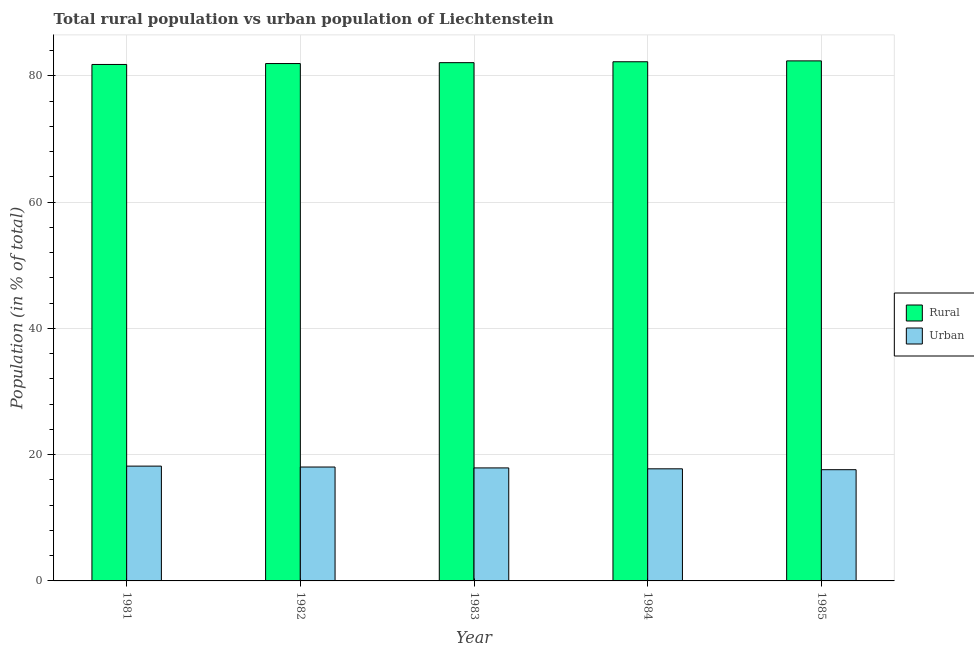How many groups of bars are there?
Ensure brevity in your answer.  5. Are the number of bars per tick equal to the number of legend labels?
Make the answer very short. Yes. How many bars are there on the 2nd tick from the left?
Your response must be concise. 2. In how many cases, is the number of bars for a given year not equal to the number of legend labels?
Provide a short and direct response. 0. What is the rural population in 1984?
Offer a very short reply. 82.24. Across all years, what is the maximum urban population?
Give a very brief answer. 18.19. Across all years, what is the minimum rural population?
Make the answer very short. 81.81. In which year was the urban population maximum?
Offer a terse response. 1981. What is the total rural population in the graph?
Provide a succinct answer. 410.49. What is the difference between the urban population in 1983 and that in 1985?
Provide a succinct answer. 0.28. What is the difference between the rural population in 1985 and the urban population in 1982?
Provide a succinct answer. 0.42. What is the average urban population per year?
Offer a very short reply. 17.9. In the year 1981, what is the difference between the rural population and urban population?
Provide a short and direct response. 0. What is the ratio of the urban population in 1982 to that in 1984?
Keep it short and to the point. 1.02. Is the rural population in 1982 less than that in 1983?
Your answer should be compact. Yes. What is the difference between the highest and the second highest rural population?
Offer a terse response. 0.14. What is the difference between the highest and the lowest rural population?
Give a very brief answer. 0.57. Is the sum of the urban population in 1981 and 1983 greater than the maximum rural population across all years?
Your answer should be compact. Yes. What does the 2nd bar from the left in 1981 represents?
Your answer should be compact. Urban. What does the 2nd bar from the right in 1984 represents?
Your answer should be compact. Rural. Does the graph contain any zero values?
Offer a very short reply. No. What is the title of the graph?
Give a very brief answer. Total rural population vs urban population of Liechtenstein. What is the label or title of the Y-axis?
Give a very brief answer. Population (in % of total). What is the Population (in % of total) in Rural in 1981?
Offer a terse response. 81.81. What is the Population (in % of total) in Urban in 1981?
Provide a short and direct response. 18.19. What is the Population (in % of total) in Rural in 1982?
Offer a terse response. 81.96. What is the Population (in % of total) of Urban in 1982?
Your response must be concise. 18.04. What is the Population (in % of total) of Rural in 1983?
Your answer should be very brief. 82.1. What is the Population (in % of total) in Urban in 1983?
Ensure brevity in your answer.  17.9. What is the Population (in % of total) in Rural in 1984?
Provide a succinct answer. 82.24. What is the Population (in % of total) of Urban in 1984?
Your answer should be compact. 17.76. What is the Population (in % of total) in Rural in 1985?
Keep it short and to the point. 82.38. What is the Population (in % of total) in Urban in 1985?
Make the answer very short. 17.62. Across all years, what is the maximum Population (in % of total) in Rural?
Your response must be concise. 82.38. Across all years, what is the maximum Population (in % of total) in Urban?
Your answer should be very brief. 18.19. Across all years, what is the minimum Population (in % of total) in Rural?
Provide a succinct answer. 81.81. Across all years, what is the minimum Population (in % of total) of Urban?
Offer a terse response. 17.62. What is the total Population (in % of total) of Rural in the graph?
Offer a terse response. 410.49. What is the total Population (in % of total) in Urban in the graph?
Keep it short and to the point. 89.51. What is the difference between the Population (in % of total) of Rural in 1981 and that in 1982?
Your answer should be compact. -0.14. What is the difference between the Population (in % of total) of Urban in 1981 and that in 1982?
Offer a terse response. 0.14. What is the difference between the Population (in % of total) in Rural in 1981 and that in 1983?
Your response must be concise. -0.29. What is the difference between the Population (in % of total) of Urban in 1981 and that in 1983?
Provide a short and direct response. 0.29. What is the difference between the Population (in % of total) of Rural in 1981 and that in 1984?
Provide a succinct answer. -0.43. What is the difference between the Population (in % of total) in Urban in 1981 and that in 1984?
Make the answer very short. 0.43. What is the difference between the Population (in % of total) of Rural in 1981 and that in 1985?
Give a very brief answer. -0.57. What is the difference between the Population (in % of total) of Urban in 1981 and that in 1985?
Give a very brief answer. 0.57. What is the difference between the Population (in % of total) in Rural in 1982 and that in 1983?
Give a very brief answer. -0.14. What is the difference between the Population (in % of total) of Urban in 1982 and that in 1983?
Give a very brief answer. 0.14. What is the difference between the Population (in % of total) in Rural in 1982 and that in 1984?
Keep it short and to the point. -0.28. What is the difference between the Population (in % of total) of Urban in 1982 and that in 1984?
Your answer should be very brief. 0.28. What is the difference between the Population (in % of total) in Rural in 1982 and that in 1985?
Keep it short and to the point. -0.42. What is the difference between the Population (in % of total) of Urban in 1982 and that in 1985?
Your response must be concise. 0.42. What is the difference between the Population (in % of total) in Rural in 1983 and that in 1984?
Give a very brief answer. -0.14. What is the difference between the Population (in % of total) of Urban in 1983 and that in 1984?
Provide a short and direct response. 0.14. What is the difference between the Population (in % of total) of Rural in 1983 and that in 1985?
Your answer should be very brief. -0.28. What is the difference between the Population (in % of total) in Urban in 1983 and that in 1985?
Provide a short and direct response. 0.28. What is the difference between the Population (in % of total) in Rural in 1984 and that in 1985?
Your response must be concise. -0.14. What is the difference between the Population (in % of total) in Urban in 1984 and that in 1985?
Give a very brief answer. 0.14. What is the difference between the Population (in % of total) of Rural in 1981 and the Population (in % of total) of Urban in 1982?
Keep it short and to the point. 63.77. What is the difference between the Population (in % of total) of Rural in 1981 and the Population (in % of total) of Urban in 1983?
Make the answer very short. 63.91. What is the difference between the Population (in % of total) of Rural in 1981 and the Population (in % of total) of Urban in 1984?
Provide a succinct answer. 64.05. What is the difference between the Population (in % of total) of Rural in 1981 and the Population (in % of total) of Urban in 1985?
Make the answer very short. 64.19. What is the difference between the Population (in % of total) of Rural in 1982 and the Population (in % of total) of Urban in 1983?
Keep it short and to the point. 64.06. What is the difference between the Population (in % of total) of Rural in 1982 and the Population (in % of total) of Urban in 1984?
Give a very brief answer. 64.2. What is the difference between the Population (in % of total) of Rural in 1982 and the Population (in % of total) of Urban in 1985?
Give a very brief answer. 64.34. What is the difference between the Population (in % of total) in Rural in 1983 and the Population (in % of total) in Urban in 1984?
Make the answer very short. 64.34. What is the difference between the Population (in % of total) of Rural in 1983 and the Population (in % of total) of Urban in 1985?
Keep it short and to the point. 64.48. What is the difference between the Population (in % of total) in Rural in 1984 and the Population (in % of total) in Urban in 1985?
Provide a short and direct response. 64.62. What is the average Population (in % of total) in Rural per year?
Provide a succinct answer. 82.1. What is the average Population (in % of total) in Urban per year?
Give a very brief answer. 17.9. In the year 1981, what is the difference between the Population (in % of total) in Rural and Population (in % of total) in Urban?
Your answer should be compact. 63.63. In the year 1982, what is the difference between the Population (in % of total) in Rural and Population (in % of total) in Urban?
Your answer should be compact. 63.91. In the year 1983, what is the difference between the Population (in % of total) in Rural and Population (in % of total) in Urban?
Offer a very short reply. 64.2. In the year 1984, what is the difference between the Population (in % of total) of Rural and Population (in % of total) of Urban?
Provide a short and direct response. 64.48. In the year 1985, what is the difference between the Population (in % of total) of Rural and Population (in % of total) of Urban?
Make the answer very short. 64.76. What is the ratio of the Population (in % of total) of Urban in 1981 to that in 1982?
Make the answer very short. 1.01. What is the ratio of the Population (in % of total) in Rural in 1981 to that in 1983?
Provide a short and direct response. 1. What is the ratio of the Population (in % of total) in Rural in 1981 to that in 1984?
Provide a short and direct response. 0.99. What is the ratio of the Population (in % of total) of Urban in 1981 to that in 1984?
Offer a terse response. 1.02. What is the ratio of the Population (in % of total) in Rural in 1981 to that in 1985?
Make the answer very short. 0.99. What is the ratio of the Population (in % of total) in Urban in 1981 to that in 1985?
Offer a terse response. 1.03. What is the ratio of the Population (in % of total) in Urban in 1982 to that in 1983?
Your answer should be compact. 1.01. What is the ratio of the Population (in % of total) in Rural in 1982 to that in 1985?
Your answer should be compact. 0.99. What is the ratio of the Population (in % of total) in Urban in 1982 to that in 1985?
Give a very brief answer. 1.02. What is the ratio of the Population (in % of total) of Rural in 1983 to that in 1984?
Keep it short and to the point. 1. What is the ratio of the Population (in % of total) in Urban in 1983 to that in 1984?
Ensure brevity in your answer.  1.01. What is the ratio of the Population (in % of total) of Rural in 1983 to that in 1985?
Make the answer very short. 1. What is the ratio of the Population (in % of total) in Rural in 1984 to that in 1985?
Offer a terse response. 1. What is the ratio of the Population (in % of total) in Urban in 1984 to that in 1985?
Keep it short and to the point. 1.01. What is the difference between the highest and the second highest Population (in % of total) in Rural?
Your answer should be compact. 0.14. What is the difference between the highest and the second highest Population (in % of total) in Urban?
Ensure brevity in your answer.  0.14. What is the difference between the highest and the lowest Population (in % of total) of Rural?
Your answer should be very brief. 0.57. What is the difference between the highest and the lowest Population (in % of total) in Urban?
Provide a short and direct response. 0.57. 